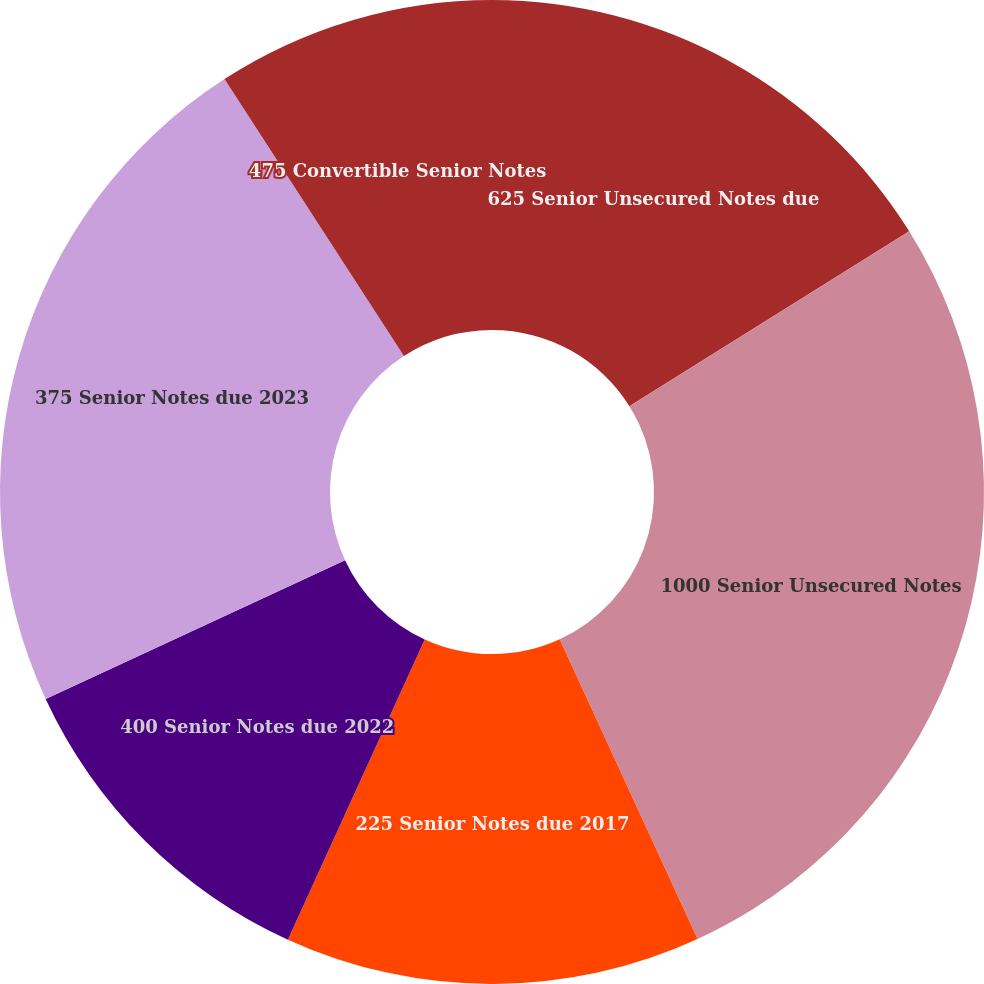<chart> <loc_0><loc_0><loc_500><loc_500><pie_chart><fcel>625 Senior Unsecured Notes due<fcel>1000 Senior Unsecured Notes<fcel>225 Senior Notes due 2017<fcel>400 Senior Notes due 2022<fcel>375 Senior Notes due 2023<fcel>475 Convertible Senior Notes<nl><fcel>16.11%<fcel>27.03%<fcel>13.67%<fcel>11.28%<fcel>22.76%<fcel>9.15%<nl></chart> 